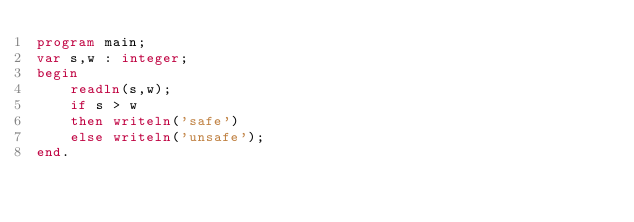<code> <loc_0><loc_0><loc_500><loc_500><_Pascal_>program main;
var s,w : integer;
begin
    readln(s,w);
    if s > w
    then writeln('safe')
    else writeln('unsafe');
end.</code> 